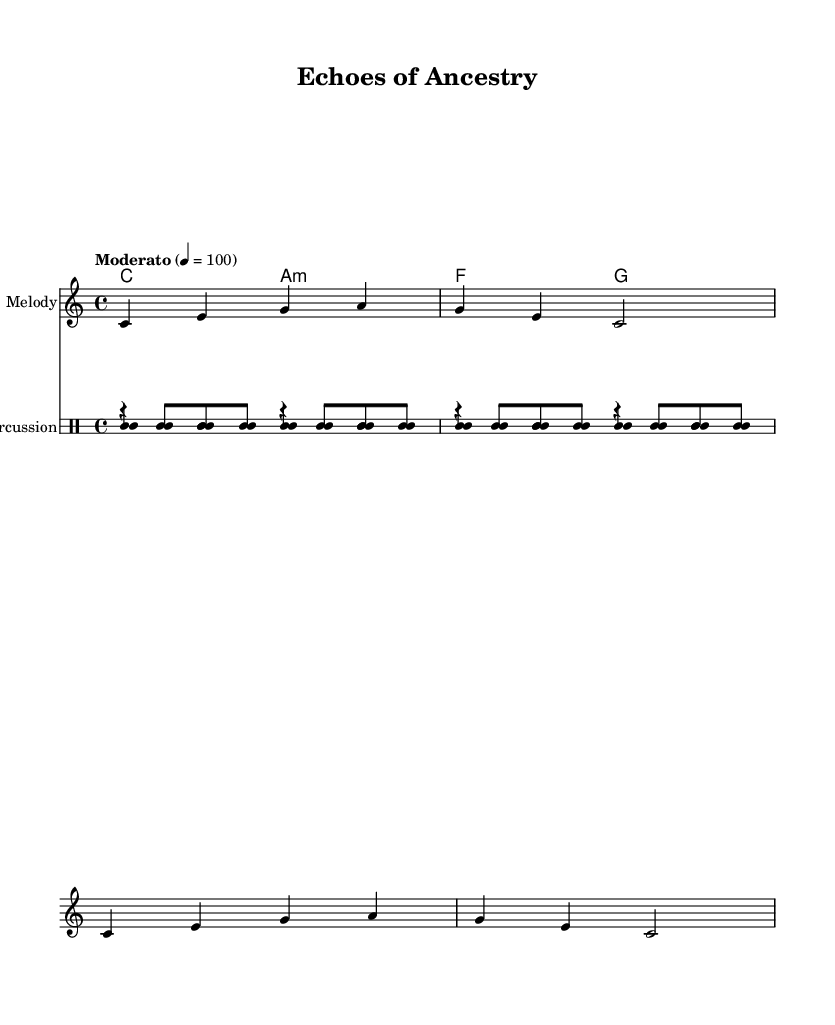What is the key signature of this music? The key signature is indicated by the lack of any sharps or flats, meaning it is in the key of C major.
Answer: C major What is the time signature of this music? The time signature is represented by the "4/4" fraction at the beginning of the piece. This indicates that there are four beats in each measure and the quarter note gets one beat.
Answer: 4/4 What is the tempo marking of this piece? The tempo marking shows "Moderato" followed by a tempo indication of 100 beats per minute, suggesting a moderate speed.
Answer: Moderato, 100 What instruments are included in the percussion section? The percussion section consists of the djembe, talking drum, and shaker, as indicated by their respective labeled drum lines in the score.
Answer: Djembe, talking drum, shaker What are the vocal lyrics for the first section? The lyrics for the vocal chant are "Ay -- oh -- ay -- oh" for the first line, which corresponds to the melody written above it.
Answer: Ay -- oh -- ay -- oh How many measures are in the djembe part? The djembe part contains two measures indicated by the separated patterns separated by vertical lines in the drum notation.
Answer: 2 What rhythmic pattern is played by the shaker? The rhythm for the shaker is shown with repeated sixteenth notes which are marked as "ss" in the notation for each measure, indicating a steady rhythm throughout.
Answer: ss 